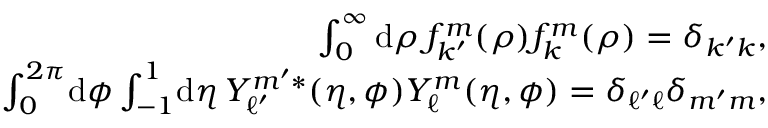Convert formula to latex. <formula><loc_0><loc_0><loc_500><loc_500>\begin{array} { r } { \int _ { 0 } ^ { \infty } d \rho \, f _ { k ^ { \prime } } ^ { m } ( \rho ) f _ { k } ^ { m } ( \rho ) = \delta _ { k ^ { \prime } k } , } \\ { \int _ { 0 } ^ { 2 \pi } \, d \phi \int _ { - 1 } ^ { 1 } \, d \eta \, Y _ { \ell ^ { \prime } } ^ { m ^ { \prime } * } ( \eta , \phi ) Y _ { \ell } ^ { m } ( \eta , \phi ) = \delta _ { \ell ^ { \prime } \ell } \delta _ { m ^ { \prime } m } , } \end{array}</formula> 